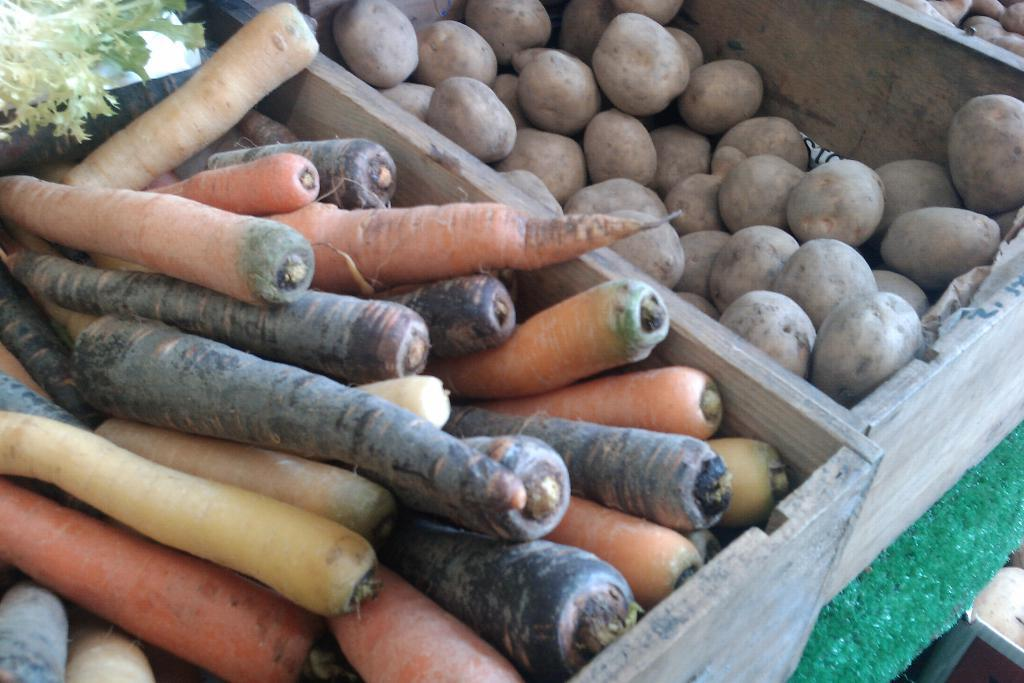What type of vegetables are in the image? There are carrots and potatoes in the image. How are the carrots and potatoes arranged in the image? The carrots and potatoes are in wooden trays. Where are the wooden trays with the vegetables placed? The wooden trays are placed on a table. What can be seen in the top left corner of the image? There are leaves visible in the top left corner of the image. What type of baseball is visible in the image? There is no baseball present in the image. Can you tell me how many balls are in the image? There are no balls visible in the image. 